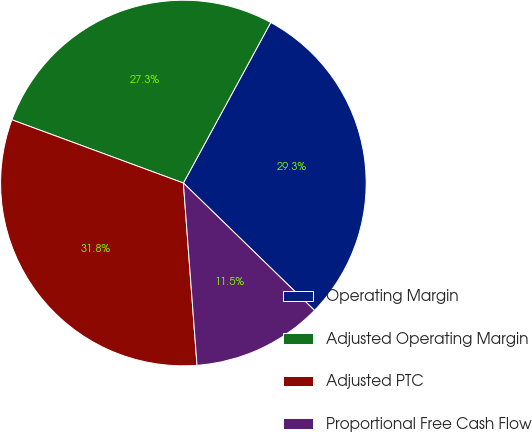Convert chart to OTSL. <chart><loc_0><loc_0><loc_500><loc_500><pie_chart><fcel>Operating Margin<fcel>Adjusted Operating Margin<fcel>Adjusted PTC<fcel>Proportional Free Cash Flow<nl><fcel>29.34%<fcel>27.31%<fcel>31.81%<fcel>11.54%<nl></chart> 